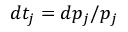<formula> <loc_0><loc_0><loc_500><loc_500>d t _ { j } = d p _ { j } / p _ { j }</formula> 